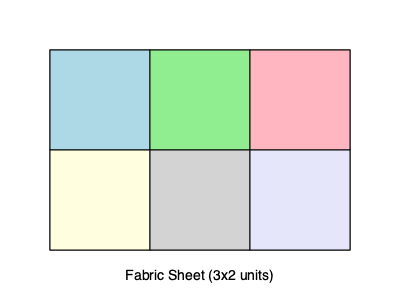Given a rectangular fabric sheet of 3x2 units as shown in the diagram, what is the maximum number of square diaper covers with side length 1 unit that can be cut from this sheet using an optimal cutting pattern? Additionally, calculate the percentage of fabric waste generated by this optimal cutting pattern. To solve this problem, we'll follow these steps:

1. Determine the total area of the fabric sheet:
   Area = Length × Width = 3 × 2 = 6 square units

2. Calculate the area of each square diaper cover:
   Area of one cover = Side length² = 1² = 1 square unit

3. Determine the maximum number of covers that can be cut:
   Since each cover requires 1 square unit, and the total area is 6 square units, we can cut a maximum of 6 covers.

4. Verify if this arrangement is possible:
   Looking at the diagram, we can see that the fabric sheet can indeed be divided into 6 equal squares of 1x1 unit each.

5. Calculate the total area used by the covers:
   Area used = Number of covers × Area of one cover
   Area used = 6 × 1 = 6 square units

6. Calculate the waste area:
   Waste area = Total fabric area - Area used by covers
   Waste area = 6 - 6 = 0 square units

7. Calculate the percentage of waste:
   Waste percentage = (Waste area / Total fabric area) × 100%
   Waste percentage = (0 / 6) × 100% = 0%

Therefore, the optimal cutting pattern allows for 6 square diaper covers to be cut from the fabric sheet with 0% waste.
Answer: 6 covers, 0% waste 